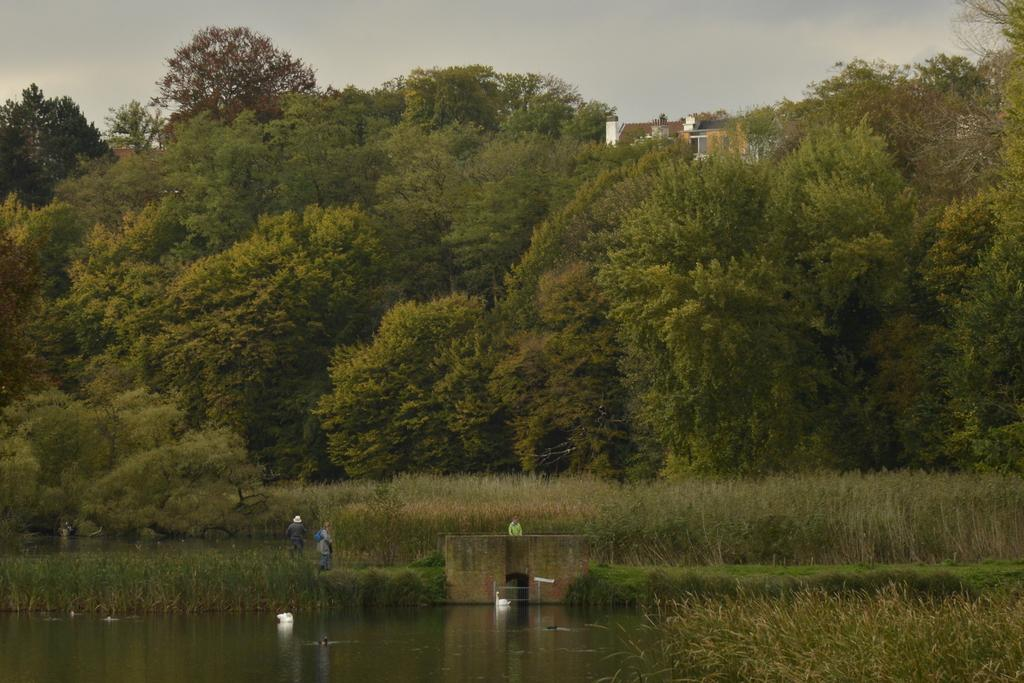What type of animals are in the water in the image? There are swans in the water in the image. What type of vegetation can be seen in the image? There is grass, plants, and trees visible in the image. How many people are standing in the image? There are three persons standing in the image. What is visible in the background of the image? The sky is visible in the background of the image. What type of quill is being used by the swans in the image? There are no quills present in the image; it features swans in the water. What is the temper of the swans in the image? There is no indication of the swans' temper in the image; they are simply swimming in the water. 